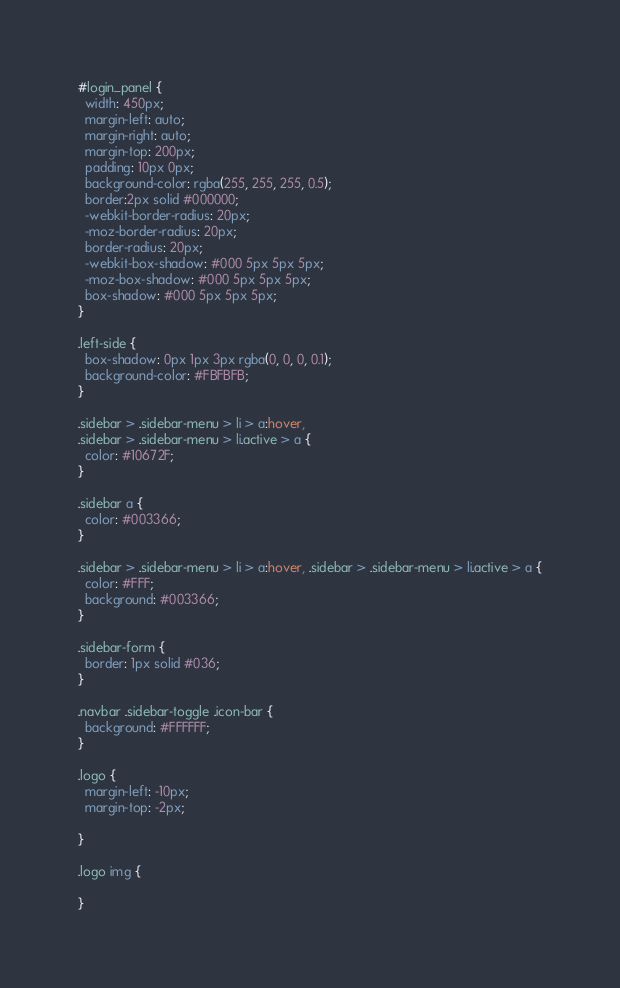Convert code to text. <code><loc_0><loc_0><loc_500><loc_500><_CSS_>#login_panel {
  width: 450px;
  margin-left: auto;
  margin-right: auto;
  margin-top: 200px;
  padding: 10px 0px;
  background-color: rgba(255, 255, 255, 0.5);
  border:2px solid #000000;
  -webkit-border-radius: 20px;
  -moz-border-radius: 20px;
  border-radius: 20px;
  -webkit-box-shadow: #000 5px 5px 5px;
  -moz-box-shadow: #000 5px 5px 5px;
  box-shadow: #000 5px 5px 5px;
}

.left-side {
  box-shadow: 0px 1px 3px rgba(0, 0, 0, 0.1);
  background-color: #FBFBFB;
}

.sidebar > .sidebar-menu > li > a:hover,
.sidebar > .sidebar-menu > li.active > a {
  color: #10672F;
}

.sidebar a {
  color: #003366;
}

.sidebar > .sidebar-menu > li > a:hover, .sidebar > .sidebar-menu > li.active > a {
  color: #FFF;
  background: #003366;
}

.sidebar-form {
  border: 1px solid #036;
}

.navbar .sidebar-toggle .icon-bar {
  background: #FFFFFF;
}

.logo {
  margin-left: -10px;
  margin-top: -2px;

}

.logo img {

}
</code> 